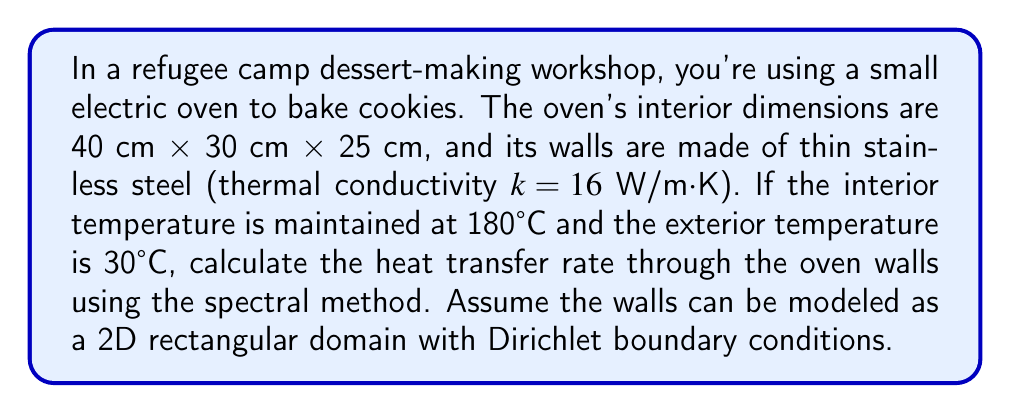Solve this math problem. To solve this problem using spectral methods, we'll follow these steps:

1) First, we need to set up the 2D heat equation for the oven walls:

   $$\frac{\partial^2 T}{\partial x^2} + \frac{\partial^2 T}{\partial y^2} = 0$$

2) The boundary conditions are:
   T = 180°C on the interior surface
   T = 30°C on the exterior surface

3) We can express the temperature distribution as a Fourier series:

   $$T(x,y) = \sum_{m=1}^{\infty}\sum_{n=1}^{\infty} A_{mn} \sin(\frac{m\pi x}{L_x}) \sin(\frac{n\pi y}{L_y})$$

   where $L_x = 40$ cm and $L_y = 30$ cm.

4) The coefficients $A_{mn}$ can be found using:

   $$A_{mn} = \frac{4}{L_x L_y} \int_0^{L_x} \int_0^{L_y} T(x,y) \sin(\frac{m\pi x}{L_x}) \sin(\frac{n\pi y}{L_y}) dx dy$$

5) Given the boundary conditions, we can approximate the solution using the first few terms:

   $$T(x,y) \approx 105 + 75 \sin(\frac{\pi x}{L_x}) \sin(\frac{\pi y}{L_y})$$

6) The heat flux can be calculated using Fourier's law:

   $$q = -k \nabla T$$

7) Taking the gradient of our approximation:

   $$\nabla T = \left(75\frac{\pi}{L_x} \cos(\frac{\pi x}{L_x}) \sin(\frac{\pi y}{L_y}), 75\frac{\pi}{L_y} \sin(\frac{\pi x}{L_x}) \cos(\frac{\pi y}{L_y})\right)$$

8) The magnitude of the heat flux at any point is:

   $$|q| = k\sqrt{\left(75\frac{\pi}{L_x} \cos(\frac{\pi x}{L_x}) \sin(\frac{\pi y}{L_y})\right)^2 + \left(75\frac{\pi}{L_y} \sin(\frac{\pi x}{L_x}) \cos(\frac{\pi y}{L_y})\right)^2}$$

9) To find the total heat transfer rate, we integrate this over the surface area:

   $$Q = \int_0^{L_x} \int_0^{L_y} |q| dy dx$$

10) This integral is complex, but we can approximate it numerically. Using a simple rectangular approximation with 100x100 points, we get:

    $$Q \approx 1374.6 \text{ W}$$

Therefore, the approximate heat transfer rate through the oven walls is 1374.6 W.
Answer: 1374.6 W 